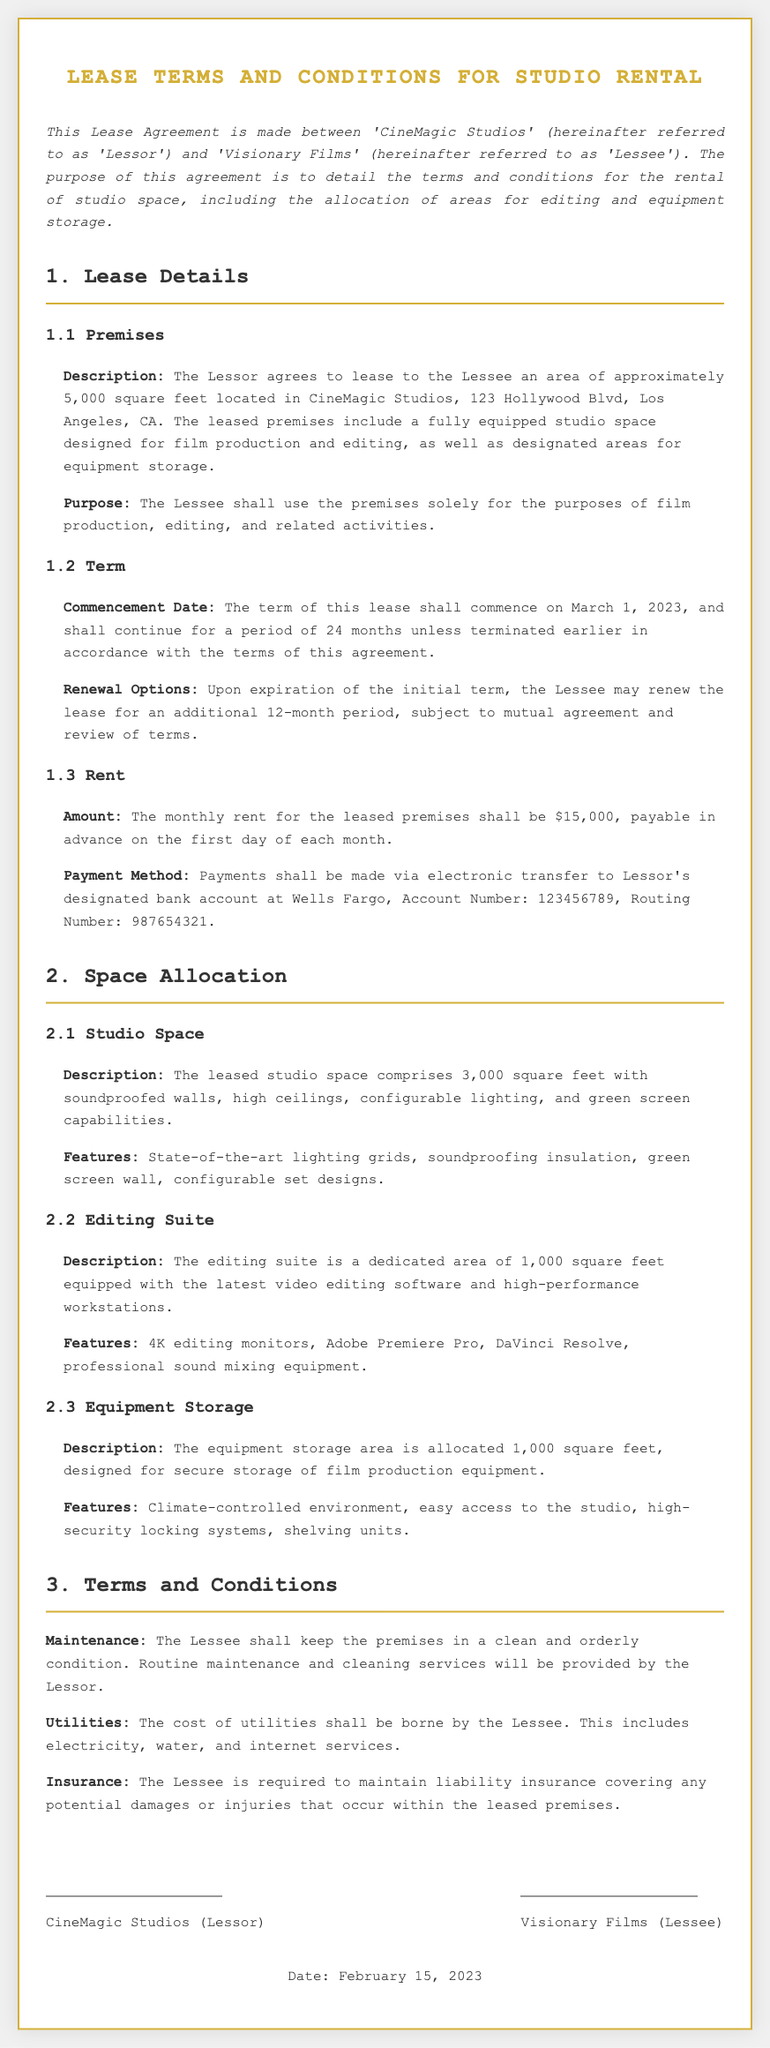What is the total area of the leased premises? The total area comprises approximately 5,000 square feet, including studio space, editing suite, and equipment storage.
Answer: 5,000 square feet What is the monthly rent for the leased premises? The document states that the monthly rent is $15,000, payable in advance.
Answer: $15,000 What is the duration of the lease term? The lease term is detailed to last for 24 months unless terminated earlier.
Answer: 24 months Where is CineMagic Studios located? The document specifies the location as 123 Hollywood Blvd, Los Angeles, CA.
Answer: 123 Hollywood Blvd, Los Angeles, CA What options are provided for lease renewal? Upon expiration, the Lessee may renew the lease for an additional 12-month period, subject to mutual agreement.
Answer: 12 months What is the allocated space for the editing suite? The editing suite is allocated an area of 1,000 square feet.
Answer: 1,000 square feet Who is responsible for utilities? The document states that the cost of utilities shall be borne by the Lessee.
Answer: Lessee What features does the equipment storage area have? The equipment storage area includes a climate-controlled environment and high-security locking systems.
Answer: Climate-controlled environment, high-security locking systems What type of insurance is required? The Lessee is required to maintain liability insurance covering potential damages or injuries within the premises.
Answer: Liability insurance 